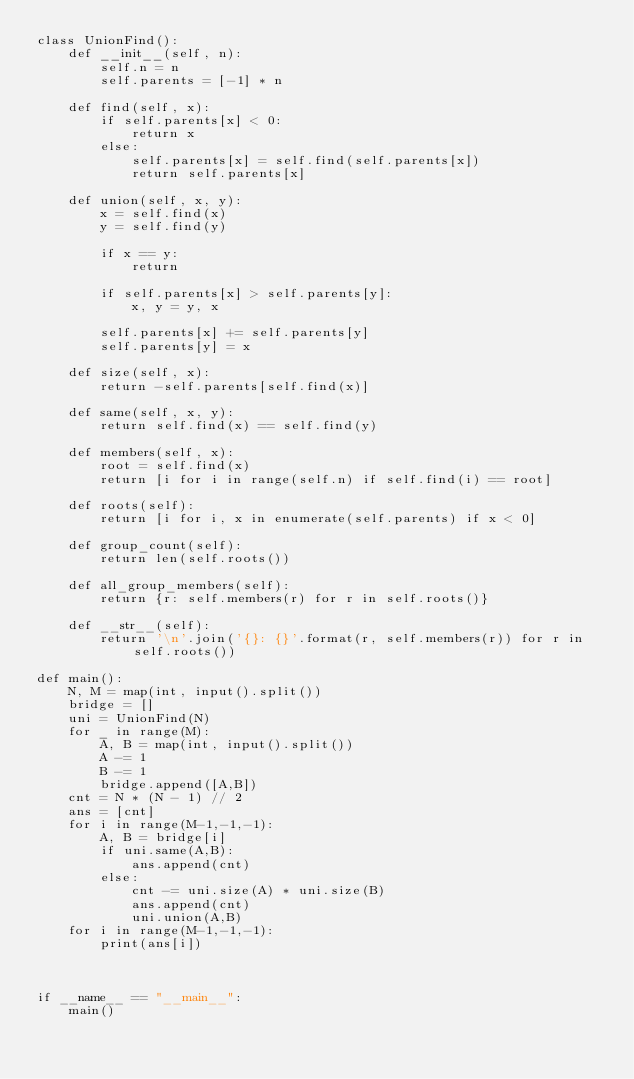Convert code to text. <code><loc_0><loc_0><loc_500><loc_500><_Python_>class UnionFind():
    def __init__(self, n):
        self.n = n
        self.parents = [-1] * n

    def find(self, x):
        if self.parents[x] < 0:
            return x
        else:
            self.parents[x] = self.find(self.parents[x])
            return self.parents[x]

    def union(self, x, y):
        x = self.find(x)
        y = self.find(y)

        if x == y:
            return

        if self.parents[x] > self.parents[y]:
            x, y = y, x

        self.parents[x] += self.parents[y]
        self.parents[y] = x

    def size(self, x):
        return -self.parents[self.find(x)]

    def same(self, x, y):
        return self.find(x) == self.find(y)

    def members(self, x):
        root = self.find(x)
        return [i for i in range(self.n) if self.find(i) == root]

    def roots(self):
        return [i for i, x in enumerate(self.parents) if x < 0]

    def group_count(self):
        return len(self.roots())

    def all_group_members(self):
        return {r: self.members(r) for r in self.roots()}

    def __str__(self):
        return '\n'.join('{}: {}'.format(r, self.members(r)) for r in self.roots())

def main():
    N, M = map(int, input().split())
    bridge = []
    uni = UnionFind(N)
    for _ in range(M):
        A, B = map(int, input().split())
        A -= 1
        B -= 1
        bridge.append([A,B])
    cnt = N * (N - 1) // 2
    ans = [cnt]
    for i in range(M-1,-1,-1):
        A, B = bridge[i]
        if uni.same(A,B):
            ans.append(cnt)
        else:
            cnt -= uni.size(A) * uni.size(B)
            ans.append(cnt)
            uni.union(A,B)
    for i in range(M-1,-1,-1):
        print(ans[i])



if __name__ == "__main__":
    main()</code> 